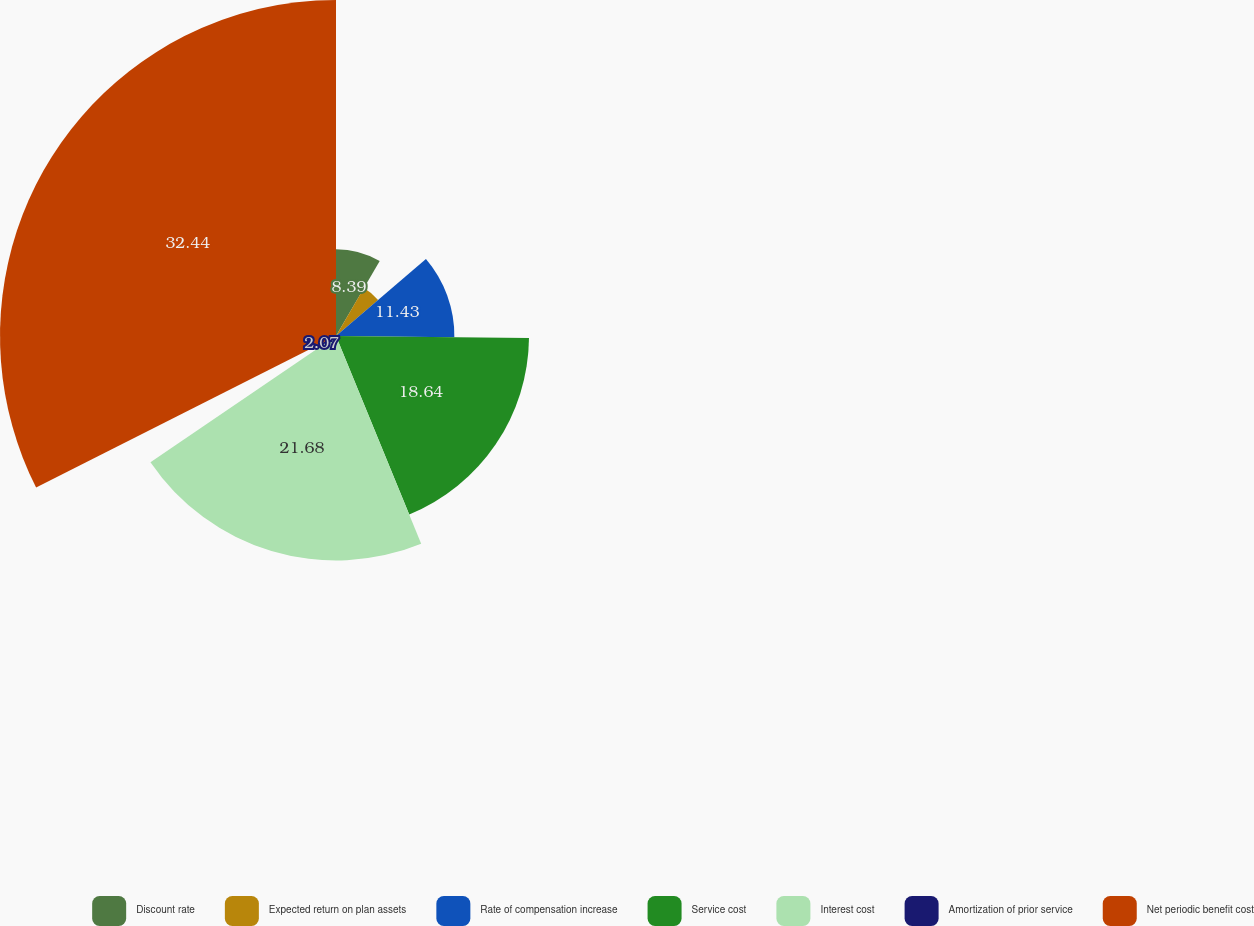Convert chart to OTSL. <chart><loc_0><loc_0><loc_500><loc_500><pie_chart><fcel>Discount rate<fcel>Expected return on plan assets<fcel>Rate of compensation increase<fcel>Service cost<fcel>Interest cost<fcel>Amortization of prior service<fcel>Net periodic benefit cost<nl><fcel>8.39%<fcel>5.35%<fcel>11.43%<fcel>18.64%<fcel>21.68%<fcel>2.07%<fcel>32.45%<nl></chart> 